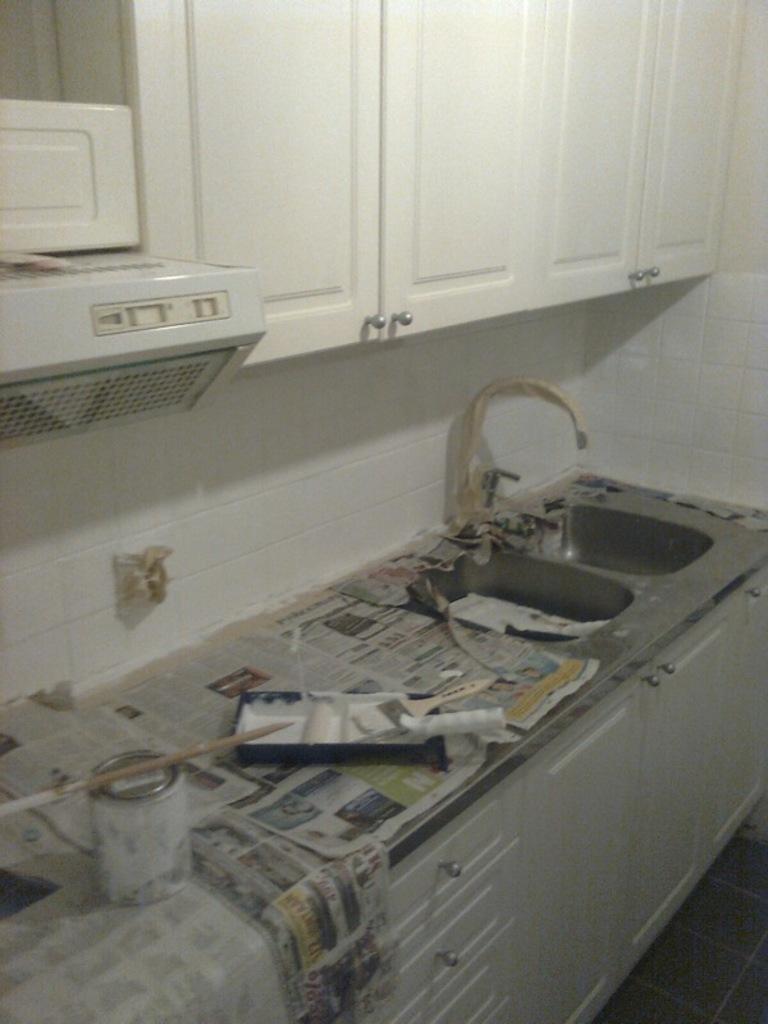Describe this image in one or two sentences. In this image we can see a paint box, brushes, newspapers, sink, tap, wooden drawers, chimney and white color wooden cupboards. 